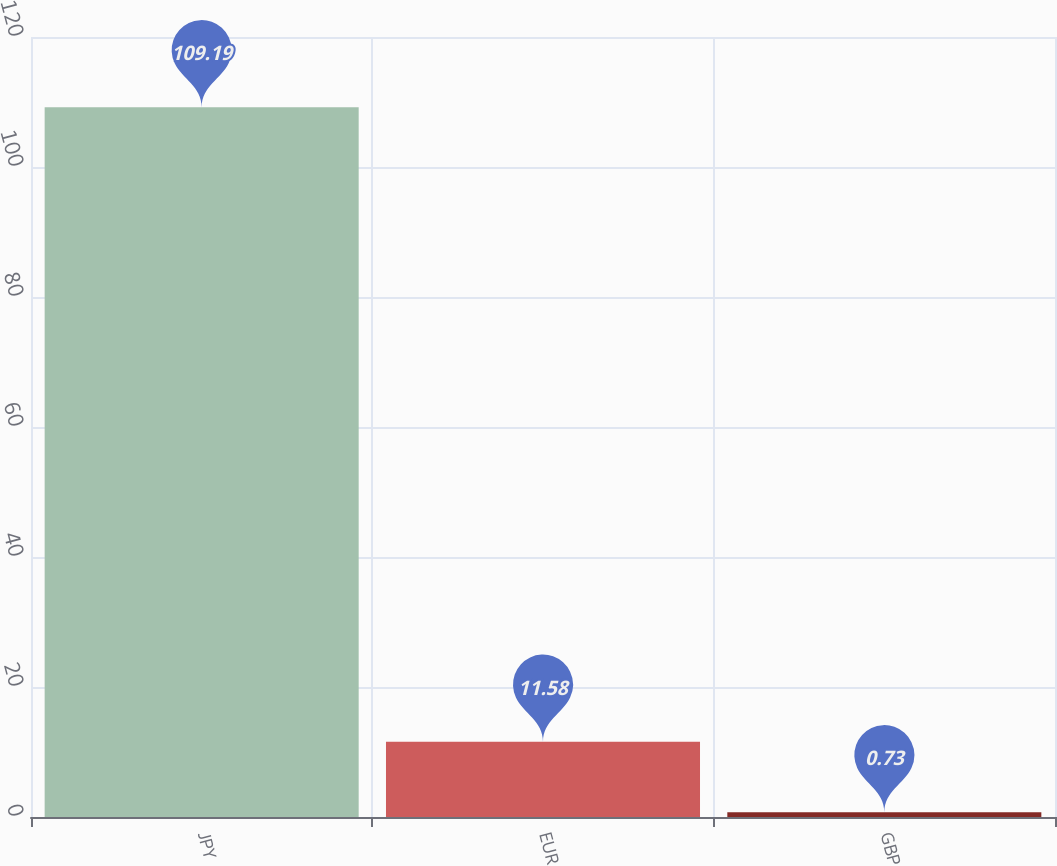<chart> <loc_0><loc_0><loc_500><loc_500><bar_chart><fcel>JPY<fcel>EUR<fcel>GBP<nl><fcel>109.19<fcel>11.58<fcel>0.73<nl></chart> 